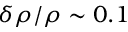<formula> <loc_0><loc_0><loc_500><loc_500>\delta \rho / \rho \sim 0 . 1</formula> 